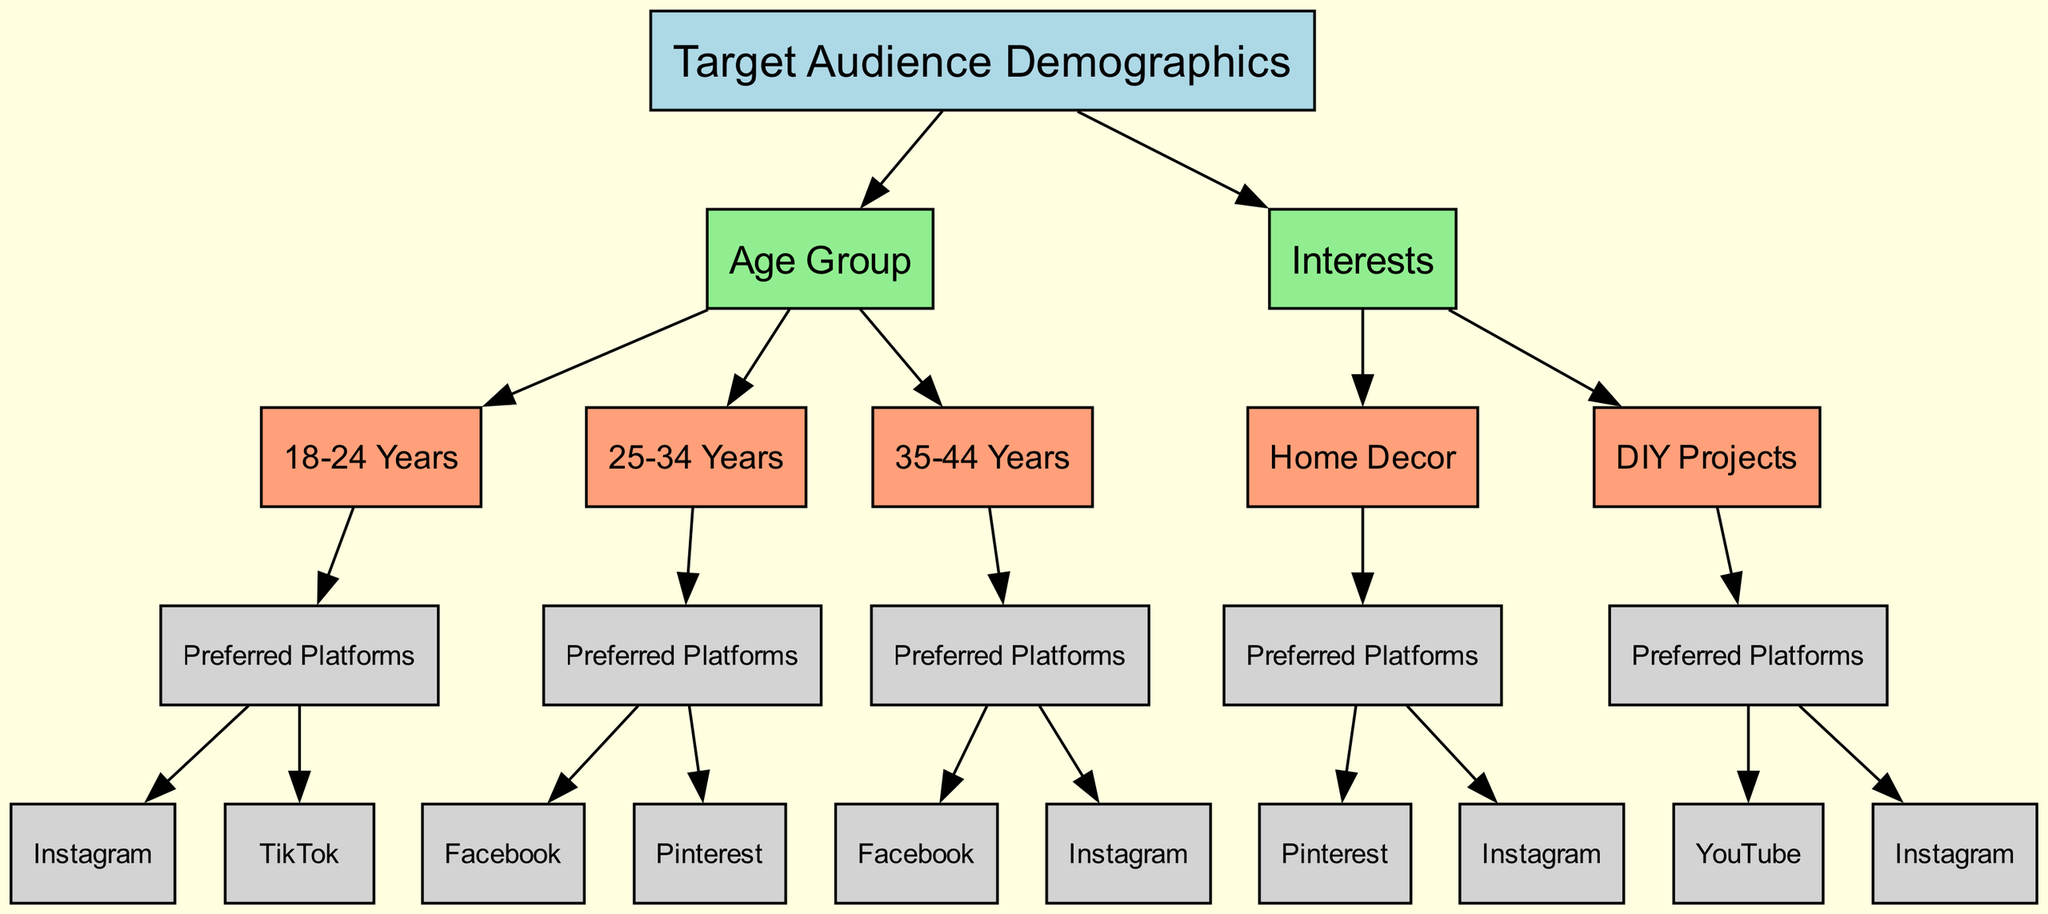What is the top-level node in the diagram? The diagram starts with the "Target Audience Demographics" which represents the main decision factor for social media platform choice.
Answer: Target Audience Demographics How many age groups are represented in the diagram? There are three age groups listed: 18-24 Years, 25-34 Years, and 35-44 Years, which are child nodes under the Age Group category.
Answer: 3 Which social media platform is preferred by the 18-24 years age group? The 18-24 Years age group prefers Instagram and TikTok, both listed under the Preferred Platforms node.
Answer: Instagram, TikTok What is the preferred platform for the interest "DIY Projects"? Under the interest "DIY Projects," the preferred platforms listed are YouTube and Instagram, showing the platforms targeted by this demographic.
Answer: YouTube, Instagram Which age group shares a preferred platform with the interest "Home Decor"? The age group of 25-34 Years shares Facebook, a preferred platform with the interest "Home Decor" node in the diagram.
Answer: 25-34 Years How many preferred platforms are listed for the 25-34 Years age group? For the 25-34 Years age group, there are two preferred platforms mentioned: Facebook and Pinterest. This can be seen under the Preferred Platforms child node.
Answer: 2 What is the relationship between "Interests" and "Preferred Platforms"? "Interests" serve as a category in the decision tree that leads to their specific "Preferred Platforms," highlighting how various interests correlate with platform choice.
Answer: Interests lead to Preferred Platforms Which demographic has a preference for Pinterest? Both the 25-34 Years age group and the Home Decor interest list Pinterest as a preferred platform under their respective nodes in the diagram.
Answer: 25-34 Years and Home Decor 